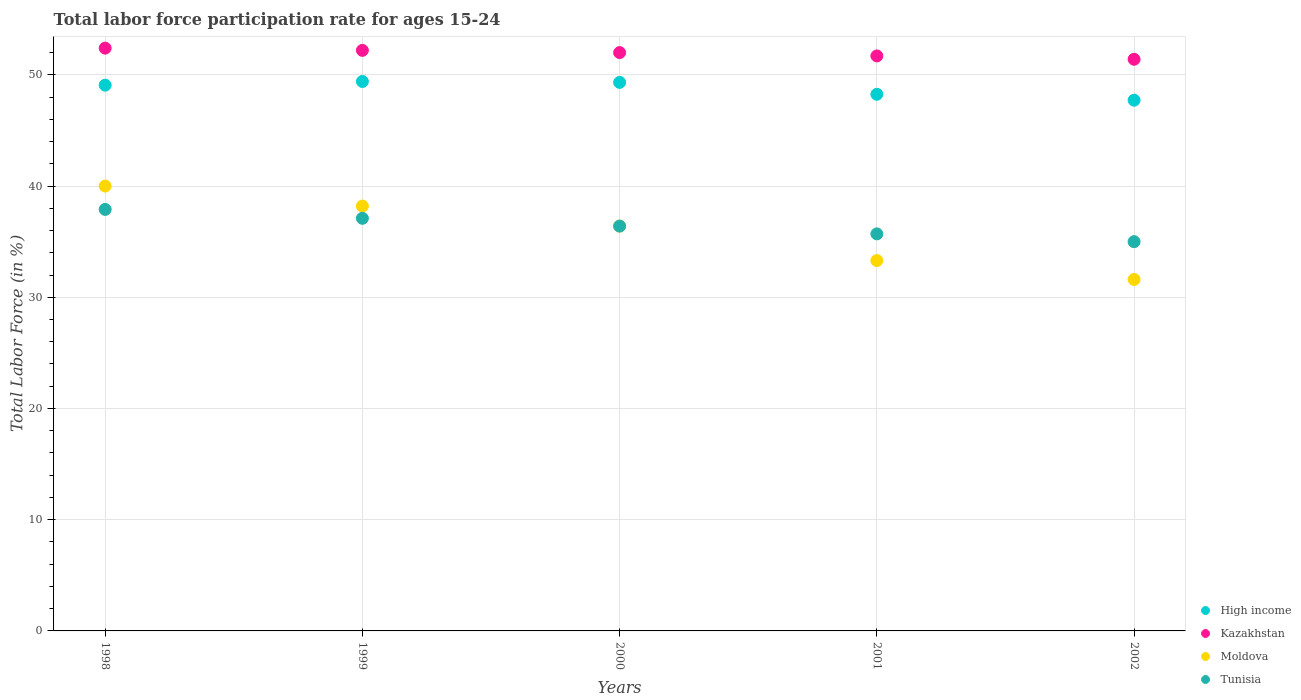How many different coloured dotlines are there?
Your answer should be compact. 4. Is the number of dotlines equal to the number of legend labels?
Your answer should be very brief. Yes. What is the labor force participation rate in High income in 2001?
Offer a very short reply. 48.25. Across all years, what is the maximum labor force participation rate in Tunisia?
Offer a very short reply. 37.9. Across all years, what is the minimum labor force participation rate in Kazakhstan?
Your answer should be compact. 51.4. In which year was the labor force participation rate in Kazakhstan minimum?
Keep it short and to the point. 2002. What is the total labor force participation rate in High income in the graph?
Provide a succinct answer. 243.76. What is the difference between the labor force participation rate in Kazakhstan in 1998 and that in 2000?
Give a very brief answer. 0.4. What is the difference between the labor force participation rate in High income in 2002 and the labor force participation rate in Kazakhstan in 1999?
Provide a short and direct response. -4.48. What is the average labor force participation rate in Moldova per year?
Offer a very short reply. 35.9. In how many years, is the labor force participation rate in Moldova greater than 46 %?
Make the answer very short. 0. What is the ratio of the labor force participation rate in Tunisia in 1998 to that in 1999?
Offer a very short reply. 1.02. Is the labor force participation rate in High income in 2000 less than that in 2002?
Your answer should be compact. No. What is the difference between the highest and the second highest labor force participation rate in Kazakhstan?
Offer a very short reply. 0.2. What is the difference between the highest and the lowest labor force participation rate in Kazakhstan?
Make the answer very short. 1. In how many years, is the labor force participation rate in Kazakhstan greater than the average labor force participation rate in Kazakhstan taken over all years?
Offer a terse response. 3. Is it the case that in every year, the sum of the labor force participation rate in Tunisia and labor force participation rate in Kazakhstan  is greater than the sum of labor force participation rate in Moldova and labor force participation rate in High income?
Your answer should be very brief. Yes. Is it the case that in every year, the sum of the labor force participation rate in High income and labor force participation rate in Kazakhstan  is greater than the labor force participation rate in Tunisia?
Give a very brief answer. Yes. Does the labor force participation rate in Tunisia monotonically increase over the years?
Your answer should be very brief. No. How many years are there in the graph?
Your answer should be compact. 5. Are the values on the major ticks of Y-axis written in scientific E-notation?
Your response must be concise. No. Does the graph contain any zero values?
Your response must be concise. No. Does the graph contain grids?
Offer a terse response. Yes. How are the legend labels stacked?
Offer a very short reply. Vertical. What is the title of the graph?
Make the answer very short. Total labor force participation rate for ages 15-24. What is the label or title of the Y-axis?
Make the answer very short. Total Labor Force (in %). What is the Total Labor Force (in %) in High income in 1998?
Your answer should be very brief. 49.07. What is the Total Labor Force (in %) of Kazakhstan in 1998?
Offer a very short reply. 52.4. What is the Total Labor Force (in %) in Tunisia in 1998?
Provide a succinct answer. 37.9. What is the Total Labor Force (in %) in High income in 1999?
Ensure brevity in your answer.  49.4. What is the Total Labor Force (in %) in Kazakhstan in 1999?
Offer a terse response. 52.2. What is the Total Labor Force (in %) in Moldova in 1999?
Keep it short and to the point. 38.2. What is the Total Labor Force (in %) in Tunisia in 1999?
Provide a succinct answer. 37.1. What is the Total Labor Force (in %) in High income in 2000?
Provide a succinct answer. 49.32. What is the Total Labor Force (in %) in Moldova in 2000?
Your response must be concise. 36.4. What is the Total Labor Force (in %) in Tunisia in 2000?
Provide a short and direct response. 36.4. What is the Total Labor Force (in %) in High income in 2001?
Your answer should be compact. 48.25. What is the Total Labor Force (in %) of Kazakhstan in 2001?
Offer a terse response. 51.7. What is the Total Labor Force (in %) of Moldova in 2001?
Your response must be concise. 33.3. What is the Total Labor Force (in %) of Tunisia in 2001?
Ensure brevity in your answer.  35.7. What is the Total Labor Force (in %) of High income in 2002?
Your answer should be very brief. 47.72. What is the Total Labor Force (in %) of Kazakhstan in 2002?
Give a very brief answer. 51.4. What is the Total Labor Force (in %) in Moldova in 2002?
Your answer should be very brief. 31.6. Across all years, what is the maximum Total Labor Force (in %) in High income?
Your answer should be compact. 49.4. Across all years, what is the maximum Total Labor Force (in %) in Kazakhstan?
Give a very brief answer. 52.4. Across all years, what is the maximum Total Labor Force (in %) in Moldova?
Make the answer very short. 40. Across all years, what is the maximum Total Labor Force (in %) in Tunisia?
Provide a short and direct response. 37.9. Across all years, what is the minimum Total Labor Force (in %) in High income?
Your answer should be very brief. 47.72. Across all years, what is the minimum Total Labor Force (in %) in Kazakhstan?
Make the answer very short. 51.4. Across all years, what is the minimum Total Labor Force (in %) in Moldova?
Offer a terse response. 31.6. What is the total Total Labor Force (in %) of High income in the graph?
Make the answer very short. 243.76. What is the total Total Labor Force (in %) of Kazakhstan in the graph?
Keep it short and to the point. 259.7. What is the total Total Labor Force (in %) of Moldova in the graph?
Your response must be concise. 179.5. What is the total Total Labor Force (in %) in Tunisia in the graph?
Keep it short and to the point. 182.1. What is the difference between the Total Labor Force (in %) in High income in 1998 and that in 1999?
Offer a terse response. -0.33. What is the difference between the Total Labor Force (in %) in Kazakhstan in 1998 and that in 1999?
Make the answer very short. 0.2. What is the difference between the Total Labor Force (in %) in Moldova in 1998 and that in 1999?
Make the answer very short. 1.8. What is the difference between the Total Labor Force (in %) in Tunisia in 1998 and that in 1999?
Your response must be concise. 0.8. What is the difference between the Total Labor Force (in %) in High income in 1998 and that in 2000?
Your answer should be compact. -0.25. What is the difference between the Total Labor Force (in %) of Moldova in 1998 and that in 2000?
Keep it short and to the point. 3.6. What is the difference between the Total Labor Force (in %) in High income in 1998 and that in 2001?
Provide a short and direct response. 0.82. What is the difference between the Total Labor Force (in %) of Kazakhstan in 1998 and that in 2001?
Your response must be concise. 0.7. What is the difference between the Total Labor Force (in %) in High income in 1998 and that in 2002?
Provide a succinct answer. 1.35. What is the difference between the Total Labor Force (in %) in Tunisia in 1998 and that in 2002?
Your answer should be very brief. 2.9. What is the difference between the Total Labor Force (in %) of High income in 1999 and that in 2000?
Keep it short and to the point. 0.08. What is the difference between the Total Labor Force (in %) of Kazakhstan in 1999 and that in 2000?
Provide a succinct answer. 0.2. What is the difference between the Total Labor Force (in %) in Tunisia in 1999 and that in 2000?
Provide a succinct answer. 0.7. What is the difference between the Total Labor Force (in %) in High income in 1999 and that in 2001?
Your answer should be very brief. 1.15. What is the difference between the Total Labor Force (in %) of Kazakhstan in 1999 and that in 2001?
Keep it short and to the point. 0.5. What is the difference between the Total Labor Force (in %) in High income in 1999 and that in 2002?
Provide a succinct answer. 1.68. What is the difference between the Total Labor Force (in %) of Kazakhstan in 1999 and that in 2002?
Provide a succinct answer. 0.8. What is the difference between the Total Labor Force (in %) in Tunisia in 1999 and that in 2002?
Your answer should be compact. 2.1. What is the difference between the Total Labor Force (in %) in High income in 2000 and that in 2001?
Your answer should be compact. 1.07. What is the difference between the Total Labor Force (in %) in Kazakhstan in 2000 and that in 2001?
Offer a very short reply. 0.3. What is the difference between the Total Labor Force (in %) in High income in 2000 and that in 2002?
Your response must be concise. 1.6. What is the difference between the Total Labor Force (in %) of Kazakhstan in 2000 and that in 2002?
Your answer should be very brief. 0.6. What is the difference between the Total Labor Force (in %) in Tunisia in 2000 and that in 2002?
Your answer should be very brief. 1.4. What is the difference between the Total Labor Force (in %) of High income in 2001 and that in 2002?
Your answer should be very brief. 0.53. What is the difference between the Total Labor Force (in %) of Kazakhstan in 2001 and that in 2002?
Your response must be concise. 0.3. What is the difference between the Total Labor Force (in %) in Moldova in 2001 and that in 2002?
Make the answer very short. 1.7. What is the difference between the Total Labor Force (in %) in Tunisia in 2001 and that in 2002?
Provide a short and direct response. 0.7. What is the difference between the Total Labor Force (in %) in High income in 1998 and the Total Labor Force (in %) in Kazakhstan in 1999?
Ensure brevity in your answer.  -3.13. What is the difference between the Total Labor Force (in %) in High income in 1998 and the Total Labor Force (in %) in Moldova in 1999?
Offer a very short reply. 10.87. What is the difference between the Total Labor Force (in %) of High income in 1998 and the Total Labor Force (in %) of Tunisia in 1999?
Give a very brief answer. 11.97. What is the difference between the Total Labor Force (in %) of Kazakhstan in 1998 and the Total Labor Force (in %) of Moldova in 1999?
Offer a very short reply. 14.2. What is the difference between the Total Labor Force (in %) in Moldova in 1998 and the Total Labor Force (in %) in Tunisia in 1999?
Ensure brevity in your answer.  2.9. What is the difference between the Total Labor Force (in %) in High income in 1998 and the Total Labor Force (in %) in Kazakhstan in 2000?
Provide a succinct answer. -2.93. What is the difference between the Total Labor Force (in %) in High income in 1998 and the Total Labor Force (in %) in Moldova in 2000?
Offer a very short reply. 12.67. What is the difference between the Total Labor Force (in %) in High income in 1998 and the Total Labor Force (in %) in Tunisia in 2000?
Provide a short and direct response. 12.67. What is the difference between the Total Labor Force (in %) in Kazakhstan in 1998 and the Total Labor Force (in %) in Moldova in 2000?
Give a very brief answer. 16. What is the difference between the Total Labor Force (in %) in Kazakhstan in 1998 and the Total Labor Force (in %) in Tunisia in 2000?
Keep it short and to the point. 16. What is the difference between the Total Labor Force (in %) in Moldova in 1998 and the Total Labor Force (in %) in Tunisia in 2000?
Provide a short and direct response. 3.6. What is the difference between the Total Labor Force (in %) in High income in 1998 and the Total Labor Force (in %) in Kazakhstan in 2001?
Offer a terse response. -2.63. What is the difference between the Total Labor Force (in %) of High income in 1998 and the Total Labor Force (in %) of Moldova in 2001?
Keep it short and to the point. 15.77. What is the difference between the Total Labor Force (in %) of High income in 1998 and the Total Labor Force (in %) of Tunisia in 2001?
Your answer should be compact. 13.37. What is the difference between the Total Labor Force (in %) in Kazakhstan in 1998 and the Total Labor Force (in %) in Moldova in 2001?
Provide a short and direct response. 19.1. What is the difference between the Total Labor Force (in %) in Kazakhstan in 1998 and the Total Labor Force (in %) in Tunisia in 2001?
Your response must be concise. 16.7. What is the difference between the Total Labor Force (in %) in High income in 1998 and the Total Labor Force (in %) in Kazakhstan in 2002?
Provide a short and direct response. -2.33. What is the difference between the Total Labor Force (in %) in High income in 1998 and the Total Labor Force (in %) in Moldova in 2002?
Give a very brief answer. 17.47. What is the difference between the Total Labor Force (in %) of High income in 1998 and the Total Labor Force (in %) of Tunisia in 2002?
Your answer should be very brief. 14.07. What is the difference between the Total Labor Force (in %) in Kazakhstan in 1998 and the Total Labor Force (in %) in Moldova in 2002?
Ensure brevity in your answer.  20.8. What is the difference between the Total Labor Force (in %) in High income in 1999 and the Total Labor Force (in %) in Kazakhstan in 2000?
Keep it short and to the point. -2.6. What is the difference between the Total Labor Force (in %) in High income in 1999 and the Total Labor Force (in %) in Moldova in 2000?
Provide a short and direct response. 13. What is the difference between the Total Labor Force (in %) in High income in 1999 and the Total Labor Force (in %) in Tunisia in 2000?
Your answer should be very brief. 13. What is the difference between the Total Labor Force (in %) of Kazakhstan in 1999 and the Total Labor Force (in %) of Moldova in 2000?
Keep it short and to the point. 15.8. What is the difference between the Total Labor Force (in %) of Kazakhstan in 1999 and the Total Labor Force (in %) of Tunisia in 2000?
Make the answer very short. 15.8. What is the difference between the Total Labor Force (in %) in Moldova in 1999 and the Total Labor Force (in %) in Tunisia in 2000?
Provide a short and direct response. 1.8. What is the difference between the Total Labor Force (in %) in High income in 1999 and the Total Labor Force (in %) in Kazakhstan in 2001?
Offer a terse response. -2.3. What is the difference between the Total Labor Force (in %) of High income in 1999 and the Total Labor Force (in %) of Moldova in 2001?
Ensure brevity in your answer.  16.1. What is the difference between the Total Labor Force (in %) of High income in 1999 and the Total Labor Force (in %) of Tunisia in 2001?
Your answer should be very brief. 13.7. What is the difference between the Total Labor Force (in %) in Moldova in 1999 and the Total Labor Force (in %) in Tunisia in 2001?
Offer a terse response. 2.5. What is the difference between the Total Labor Force (in %) of High income in 1999 and the Total Labor Force (in %) of Kazakhstan in 2002?
Offer a very short reply. -2. What is the difference between the Total Labor Force (in %) in High income in 1999 and the Total Labor Force (in %) in Moldova in 2002?
Your response must be concise. 17.8. What is the difference between the Total Labor Force (in %) in High income in 1999 and the Total Labor Force (in %) in Tunisia in 2002?
Keep it short and to the point. 14.4. What is the difference between the Total Labor Force (in %) in Kazakhstan in 1999 and the Total Labor Force (in %) in Moldova in 2002?
Your answer should be very brief. 20.6. What is the difference between the Total Labor Force (in %) in High income in 2000 and the Total Labor Force (in %) in Kazakhstan in 2001?
Offer a very short reply. -2.38. What is the difference between the Total Labor Force (in %) of High income in 2000 and the Total Labor Force (in %) of Moldova in 2001?
Make the answer very short. 16.02. What is the difference between the Total Labor Force (in %) in High income in 2000 and the Total Labor Force (in %) in Tunisia in 2001?
Provide a succinct answer. 13.62. What is the difference between the Total Labor Force (in %) in Moldova in 2000 and the Total Labor Force (in %) in Tunisia in 2001?
Ensure brevity in your answer.  0.7. What is the difference between the Total Labor Force (in %) of High income in 2000 and the Total Labor Force (in %) of Kazakhstan in 2002?
Your response must be concise. -2.08. What is the difference between the Total Labor Force (in %) of High income in 2000 and the Total Labor Force (in %) of Moldova in 2002?
Provide a short and direct response. 17.72. What is the difference between the Total Labor Force (in %) of High income in 2000 and the Total Labor Force (in %) of Tunisia in 2002?
Your answer should be compact. 14.32. What is the difference between the Total Labor Force (in %) of Kazakhstan in 2000 and the Total Labor Force (in %) of Moldova in 2002?
Offer a very short reply. 20.4. What is the difference between the Total Labor Force (in %) of High income in 2001 and the Total Labor Force (in %) of Kazakhstan in 2002?
Your answer should be very brief. -3.15. What is the difference between the Total Labor Force (in %) in High income in 2001 and the Total Labor Force (in %) in Moldova in 2002?
Offer a terse response. 16.65. What is the difference between the Total Labor Force (in %) of High income in 2001 and the Total Labor Force (in %) of Tunisia in 2002?
Offer a very short reply. 13.25. What is the difference between the Total Labor Force (in %) in Kazakhstan in 2001 and the Total Labor Force (in %) in Moldova in 2002?
Make the answer very short. 20.1. What is the difference between the Total Labor Force (in %) of Kazakhstan in 2001 and the Total Labor Force (in %) of Tunisia in 2002?
Ensure brevity in your answer.  16.7. What is the average Total Labor Force (in %) in High income per year?
Offer a very short reply. 48.75. What is the average Total Labor Force (in %) of Kazakhstan per year?
Your answer should be very brief. 51.94. What is the average Total Labor Force (in %) of Moldova per year?
Ensure brevity in your answer.  35.9. What is the average Total Labor Force (in %) in Tunisia per year?
Offer a terse response. 36.42. In the year 1998, what is the difference between the Total Labor Force (in %) in High income and Total Labor Force (in %) in Kazakhstan?
Offer a terse response. -3.33. In the year 1998, what is the difference between the Total Labor Force (in %) of High income and Total Labor Force (in %) of Moldova?
Give a very brief answer. 9.07. In the year 1998, what is the difference between the Total Labor Force (in %) in High income and Total Labor Force (in %) in Tunisia?
Ensure brevity in your answer.  11.17. In the year 1998, what is the difference between the Total Labor Force (in %) in Kazakhstan and Total Labor Force (in %) in Tunisia?
Your answer should be very brief. 14.5. In the year 1998, what is the difference between the Total Labor Force (in %) of Moldova and Total Labor Force (in %) of Tunisia?
Your answer should be compact. 2.1. In the year 1999, what is the difference between the Total Labor Force (in %) in High income and Total Labor Force (in %) in Kazakhstan?
Your answer should be compact. -2.8. In the year 1999, what is the difference between the Total Labor Force (in %) of High income and Total Labor Force (in %) of Moldova?
Your response must be concise. 11.2. In the year 1999, what is the difference between the Total Labor Force (in %) of High income and Total Labor Force (in %) of Tunisia?
Keep it short and to the point. 12.3. In the year 1999, what is the difference between the Total Labor Force (in %) in Kazakhstan and Total Labor Force (in %) in Moldova?
Your answer should be compact. 14. In the year 2000, what is the difference between the Total Labor Force (in %) of High income and Total Labor Force (in %) of Kazakhstan?
Give a very brief answer. -2.68. In the year 2000, what is the difference between the Total Labor Force (in %) of High income and Total Labor Force (in %) of Moldova?
Ensure brevity in your answer.  12.92. In the year 2000, what is the difference between the Total Labor Force (in %) in High income and Total Labor Force (in %) in Tunisia?
Your answer should be compact. 12.92. In the year 2001, what is the difference between the Total Labor Force (in %) in High income and Total Labor Force (in %) in Kazakhstan?
Provide a short and direct response. -3.45. In the year 2001, what is the difference between the Total Labor Force (in %) of High income and Total Labor Force (in %) of Moldova?
Your answer should be very brief. 14.95. In the year 2001, what is the difference between the Total Labor Force (in %) of High income and Total Labor Force (in %) of Tunisia?
Your answer should be very brief. 12.55. In the year 2001, what is the difference between the Total Labor Force (in %) in Kazakhstan and Total Labor Force (in %) in Tunisia?
Offer a terse response. 16. In the year 2001, what is the difference between the Total Labor Force (in %) of Moldova and Total Labor Force (in %) of Tunisia?
Keep it short and to the point. -2.4. In the year 2002, what is the difference between the Total Labor Force (in %) in High income and Total Labor Force (in %) in Kazakhstan?
Offer a terse response. -3.68. In the year 2002, what is the difference between the Total Labor Force (in %) in High income and Total Labor Force (in %) in Moldova?
Provide a succinct answer. 16.12. In the year 2002, what is the difference between the Total Labor Force (in %) of High income and Total Labor Force (in %) of Tunisia?
Keep it short and to the point. 12.72. In the year 2002, what is the difference between the Total Labor Force (in %) in Kazakhstan and Total Labor Force (in %) in Moldova?
Provide a succinct answer. 19.8. In the year 2002, what is the difference between the Total Labor Force (in %) in Moldova and Total Labor Force (in %) in Tunisia?
Keep it short and to the point. -3.4. What is the ratio of the Total Labor Force (in %) in High income in 1998 to that in 1999?
Make the answer very short. 0.99. What is the ratio of the Total Labor Force (in %) of Moldova in 1998 to that in 1999?
Provide a short and direct response. 1.05. What is the ratio of the Total Labor Force (in %) of Tunisia in 1998 to that in 1999?
Make the answer very short. 1.02. What is the ratio of the Total Labor Force (in %) in Kazakhstan in 1998 to that in 2000?
Your answer should be compact. 1.01. What is the ratio of the Total Labor Force (in %) of Moldova in 1998 to that in 2000?
Your answer should be compact. 1.1. What is the ratio of the Total Labor Force (in %) in Tunisia in 1998 to that in 2000?
Your response must be concise. 1.04. What is the ratio of the Total Labor Force (in %) in Kazakhstan in 1998 to that in 2001?
Offer a very short reply. 1.01. What is the ratio of the Total Labor Force (in %) in Moldova in 1998 to that in 2001?
Offer a terse response. 1.2. What is the ratio of the Total Labor Force (in %) in Tunisia in 1998 to that in 2001?
Provide a succinct answer. 1.06. What is the ratio of the Total Labor Force (in %) in High income in 1998 to that in 2002?
Ensure brevity in your answer.  1.03. What is the ratio of the Total Labor Force (in %) of Kazakhstan in 1998 to that in 2002?
Your answer should be compact. 1.02. What is the ratio of the Total Labor Force (in %) of Moldova in 1998 to that in 2002?
Provide a succinct answer. 1.27. What is the ratio of the Total Labor Force (in %) in Tunisia in 1998 to that in 2002?
Provide a short and direct response. 1.08. What is the ratio of the Total Labor Force (in %) in Moldova in 1999 to that in 2000?
Your answer should be very brief. 1.05. What is the ratio of the Total Labor Force (in %) of Tunisia in 1999 to that in 2000?
Give a very brief answer. 1.02. What is the ratio of the Total Labor Force (in %) in High income in 1999 to that in 2001?
Your answer should be very brief. 1.02. What is the ratio of the Total Labor Force (in %) of Kazakhstan in 1999 to that in 2001?
Offer a very short reply. 1.01. What is the ratio of the Total Labor Force (in %) in Moldova in 1999 to that in 2001?
Your answer should be compact. 1.15. What is the ratio of the Total Labor Force (in %) of Tunisia in 1999 to that in 2001?
Keep it short and to the point. 1.04. What is the ratio of the Total Labor Force (in %) in High income in 1999 to that in 2002?
Give a very brief answer. 1.04. What is the ratio of the Total Labor Force (in %) in Kazakhstan in 1999 to that in 2002?
Your response must be concise. 1.02. What is the ratio of the Total Labor Force (in %) in Moldova in 1999 to that in 2002?
Provide a short and direct response. 1.21. What is the ratio of the Total Labor Force (in %) of Tunisia in 1999 to that in 2002?
Offer a terse response. 1.06. What is the ratio of the Total Labor Force (in %) in High income in 2000 to that in 2001?
Keep it short and to the point. 1.02. What is the ratio of the Total Labor Force (in %) of Moldova in 2000 to that in 2001?
Ensure brevity in your answer.  1.09. What is the ratio of the Total Labor Force (in %) in Tunisia in 2000 to that in 2001?
Provide a short and direct response. 1.02. What is the ratio of the Total Labor Force (in %) of High income in 2000 to that in 2002?
Offer a terse response. 1.03. What is the ratio of the Total Labor Force (in %) in Kazakhstan in 2000 to that in 2002?
Make the answer very short. 1.01. What is the ratio of the Total Labor Force (in %) in Moldova in 2000 to that in 2002?
Ensure brevity in your answer.  1.15. What is the ratio of the Total Labor Force (in %) in High income in 2001 to that in 2002?
Your answer should be compact. 1.01. What is the ratio of the Total Labor Force (in %) in Kazakhstan in 2001 to that in 2002?
Offer a terse response. 1.01. What is the ratio of the Total Labor Force (in %) in Moldova in 2001 to that in 2002?
Offer a terse response. 1.05. What is the ratio of the Total Labor Force (in %) in Tunisia in 2001 to that in 2002?
Offer a terse response. 1.02. What is the difference between the highest and the second highest Total Labor Force (in %) of High income?
Make the answer very short. 0.08. What is the difference between the highest and the second highest Total Labor Force (in %) of Kazakhstan?
Your answer should be very brief. 0.2. What is the difference between the highest and the second highest Total Labor Force (in %) of Moldova?
Your response must be concise. 1.8. What is the difference between the highest and the second highest Total Labor Force (in %) in Tunisia?
Provide a short and direct response. 0.8. What is the difference between the highest and the lowest Total Labor Force (in %) in High income?
Provide a short and direct response. 1.68. What is the difference between the highest and the lowest Total Labor Force (in %) of Kazakhstan?
Make the answer very short. 1. What is the difference between the highest and the lowest Total Labor Force (in %) in Moldova?
Your answer should be compact. 8.4. What is the difference between the highest and the lowest Total Labor Force (in %) in Tunisia?
Your response must be concise. 2.9. 